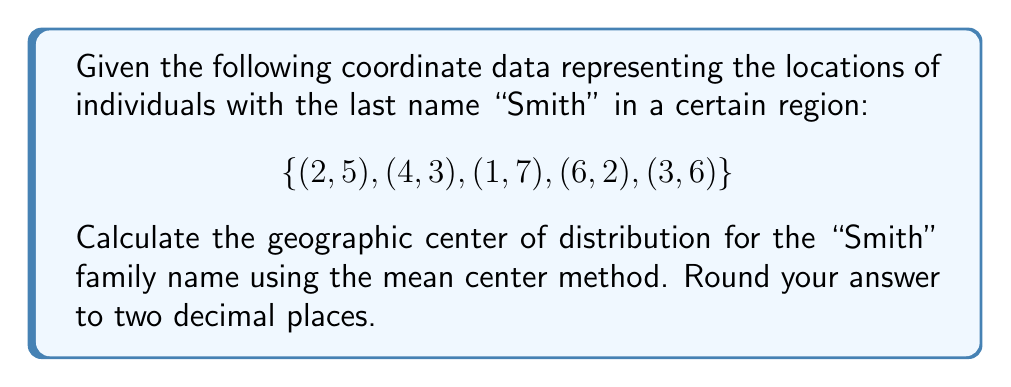Show me your answer to this math problem. To determine the geographic center of distribution for the "Smith" family name using the mean center method, we need to calculate the average of the x-coordinates and y-coordinates separately.

Step 1: Calculate the mean of x-coordinates
$$\bar{x} = \frac{x_1 + x_2 + x_3 + x_4 + x_5}{n}$$
$$\bar{x} = \frac{2 + 4 + 1 + 6 + 3}{5} = \frac{16}{5} = 3.2$$

Step 2: Calculate the mean of y-coordinates
$$\bar{y} = \frac{y_1 + y_2 + y_3 + y_4 + y_5}{n}$$
$$\bar{y} = \frac{5 + 3 + 7 + 2 + 6}{5} = \frac{23}{5} = 4.6$$

Step 3: The geographic center of distribution is the point $(\bar{x}, \bar{y})$, which in this case is $(3.2, 4.6)$.

This point represents the average location of all individuals with the last name "Smith" in the given region.
Answer: $(3.2, 4.6)$ 